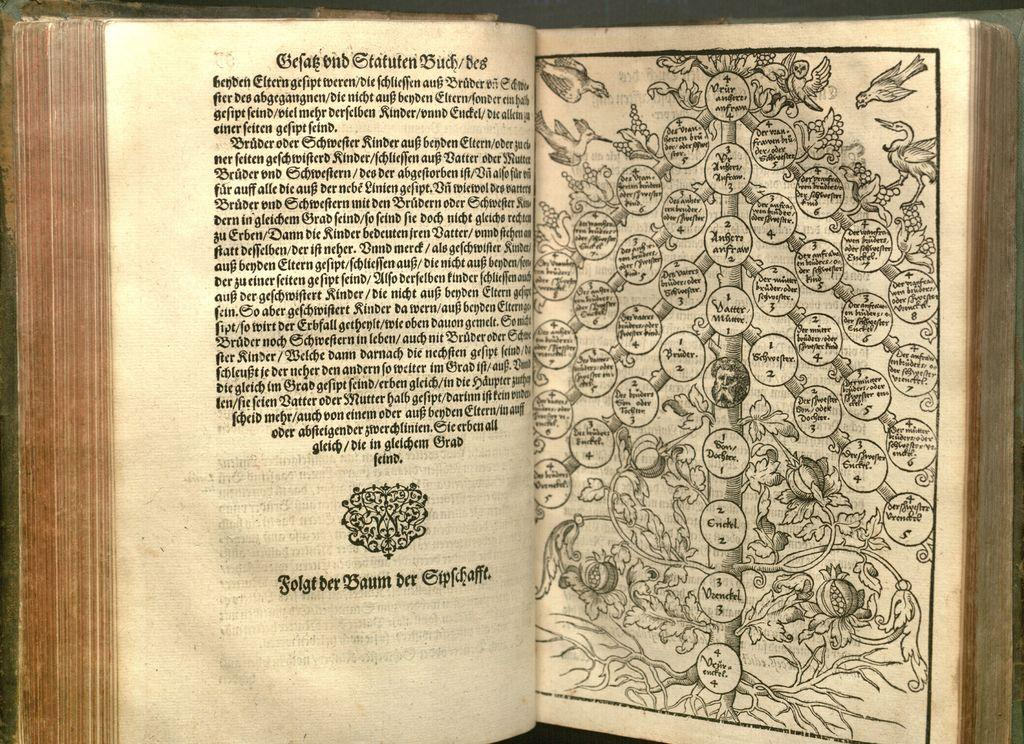<image>
Offer a succinct explanation of the picture presented. Open book that has a graph showing bubbles with numbers including number 4. 